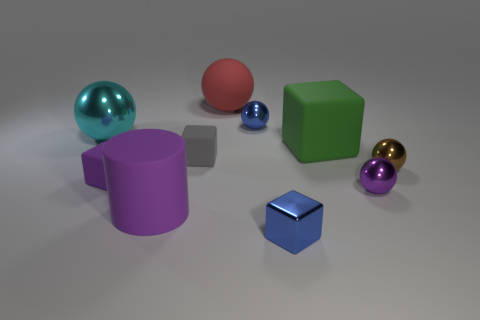How many small objects are brown shiny cubes or cyan objects? In the image, there appears to be one small brown shiny cube and two cyan objects, which together makes three small objects that meet the criteria. 